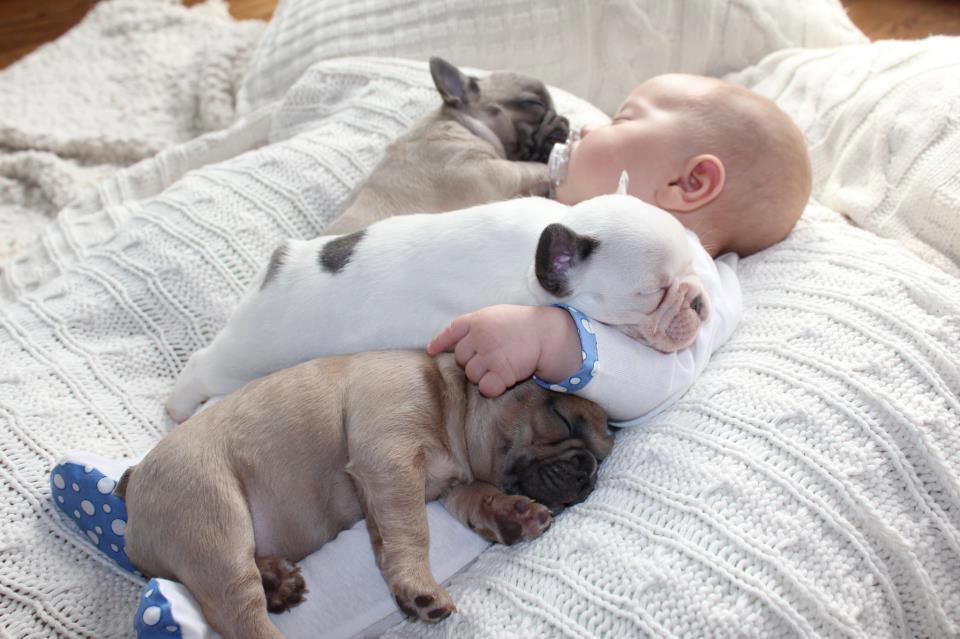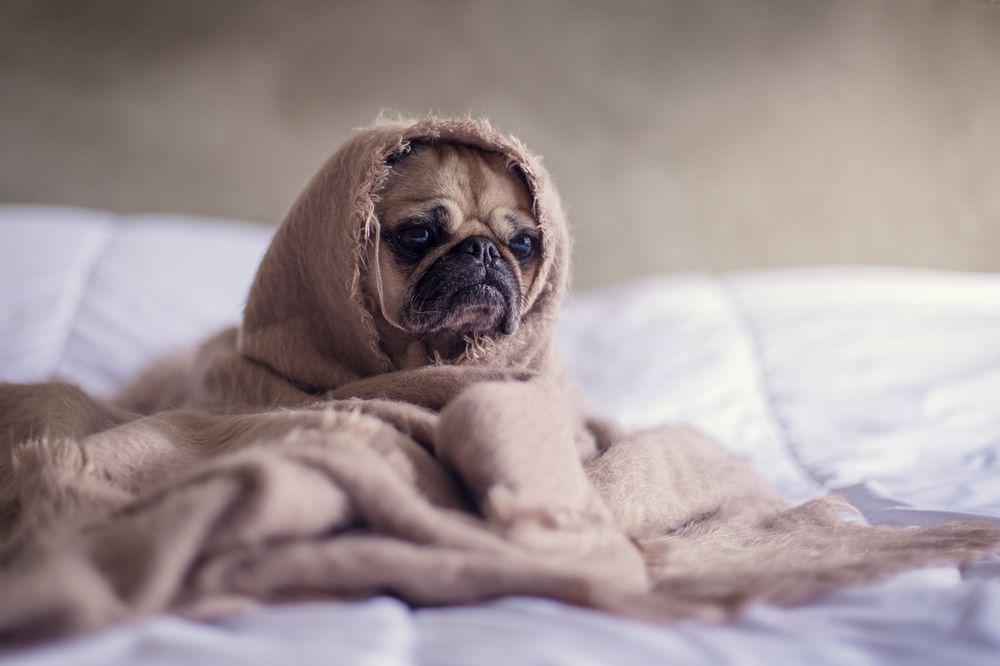The first image is the image on the left, the second image is the image on the right. Evaluate the accuracy of this statement regarding the images: "There is exactly 1 puppy lying down in the image on the left.". Is it true? Answer yes or no. No. The first image is the image on the left, the second image is the image on the right. For the images displayed, is the sentence "One image shows a pug puppy with its head resting on the fur of a real animal, and the other image shows one real pug with its head resting on something plush." factually correct? Answer yes or no. No. 